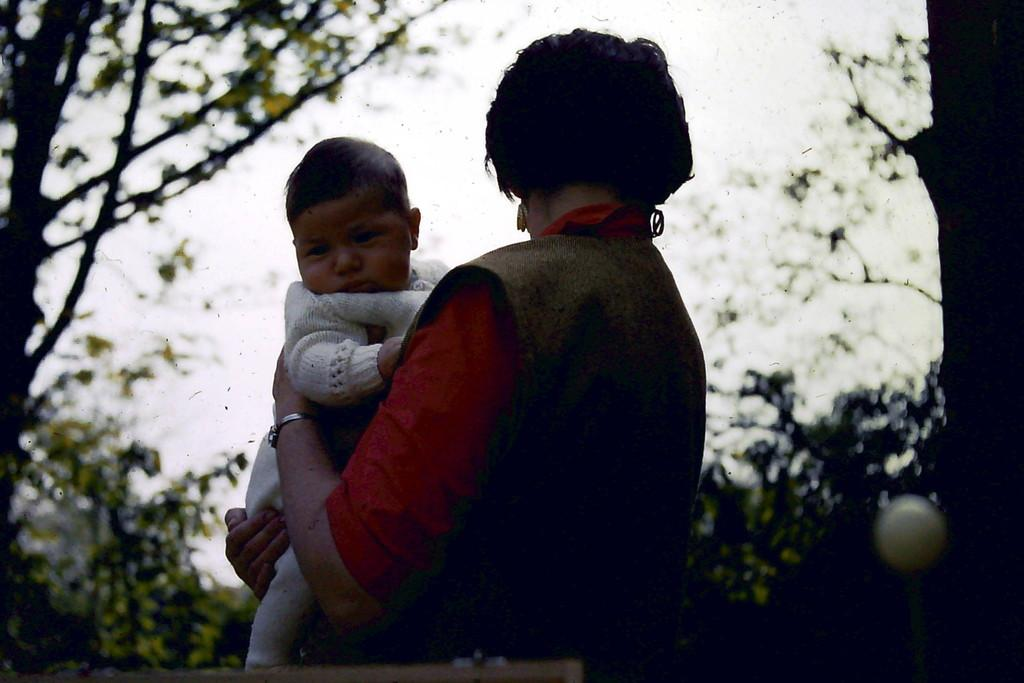What is the main subject of the image? The main subject of the image is a woman. What is the woman doing in the image? The woman is holding a baby with her hand. What type of value is the woman holding in the image? There is no value present in the image; the woman is holding a baby with her hand. Can you see any army personnel or equipment in the image? There is no army personnel or equipment present in the image. Is there a cobweb visible in the image? There is no cobweb present in the image. 